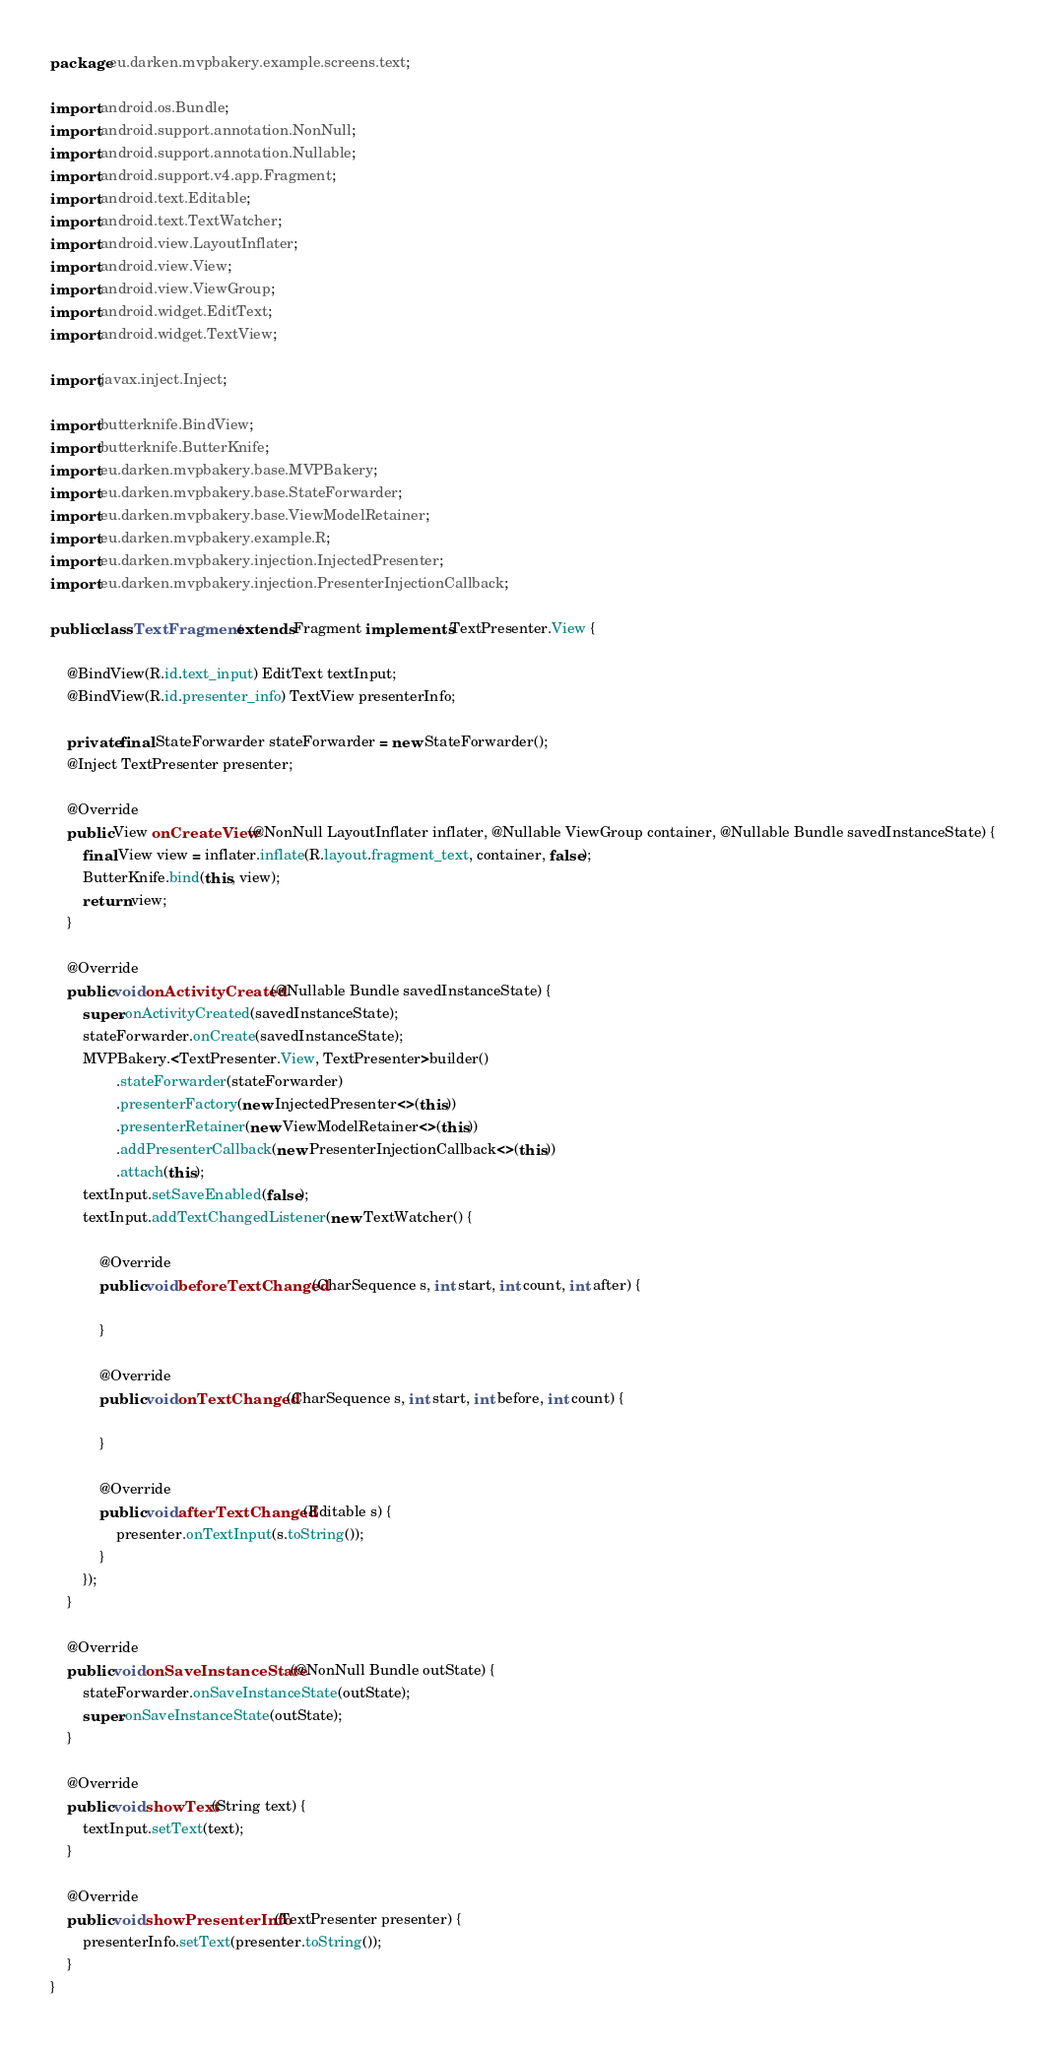<code> <loc_0><loc_0><loc_500><loc_500><_Java_>package eu.darken.mvpbakery.example.screens.text;

import android.os.Bundle;
import android.support.annotation.NonNull;
import android.support.annotation.Nullable;
import android.support.v4.app.Fragment;
import android.text.Editable;
import android.text.TextWatcher;
import android.view.LayoutInflater;
import android.view.View;
import android.view.ViewGroup;
import android.widget.EditText;
import android.widget.TextView;

import javax.inject.Inject;

import butterknife.BindView;
import butterknife.ButterKnife;
import eu.darken.mvpbakery.base.MVPBakery;
import eu.darken.mvpbakery.base.StateForwarder;
import eu.darken.mvpbakery.base.ViewModelRetainer;
import eu.darken.mvpbakery.example.R;
import eu.darken.mvpbakery.injection.InjectedPresenter;
import eu.darken.mvpbakery.injection.PresenterInjectionCallback;

public class TextFragment extends Fragment implements TextPresenter.View {

    @BindView(R.id.text_input) EditText textInput;
    @BindView(R.id.presenter_info) TextView presenterInfo;

    private final StateForwarder stateForwarder = new StateForwarder();
    @Inject TextPresenter presenter;

    @Override
    public View onCreateView(@NonNull LayoutInflater inflater, @Nullable ViewGroup container, @Nullable Bundle savedInstanceState) {
        final View view = inflater.inflate(R.layout.fragment_text, container, false);
        ButterKnife.bind(this, view);
        return view;
    }

    @Override
    public void onActivityCreated(@Nullable Bundle savedInstanceState) {
        super.onActivityCreated(savedInstanceState);
        stateForwarder.onCreate(savedInstanceState);
        MVPBakery.<TextPresenter.View, TextPresenter>builder()
                .stateForwarder(stateForwarder)
                .presenterFactory(new InjectedPresenter<>(this))
                .presenterRetainer(new ViewModelRetainer<>(this))
                .addPresenterCallback(new PresenterInjectionCallback<>(this))
                .attach(this);
        textInput.setSaveEnabled(false);
        textInput.addTextChangedListener(new TextWatcher() {

            @Override
            public void beforeTextChanged(CharSequence s, int start, int count, int after) {

            }

            @Override
            public void onTextChanged(CharSequence s, int start, int before, int count) {

            }

            @Override
            public void afterTextChanged(Editable s) {
                presenter.onTextInput(s.toString());
            }
        });
    }

    @Override
    public void onSaveInstanceState(@NonNull Bundle outState) {
        stateForwarder.onSaveInstanceState(outState);
        super.onSaveInstanceState(outState);
    }

    @Override
    public void showText(String text) {
        textInput.setText(text);
    }

    @Override
    public void showPresenterInfo(TextPresenter presenter) {
        presenterInfo.setText(presenter.toString());
    }
}
</code> 